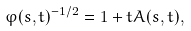Convert formula to latex. <formula><loc_0><loc_0><loc_500><loc_500>\varphi ( s , t ) ^ { - 1 / 2 } = 1 + t A ( s , t ) ,</formula> 